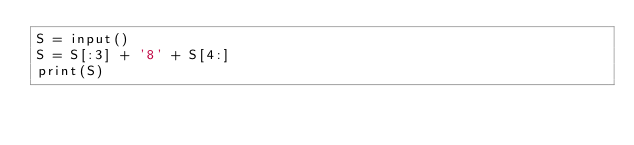Convert code to text. <code><loc_0><loc_0><loc_500><loc_500><_Python_>S = input()
S = S[:3] + '8' + S[4:]
print(S)
</code> 